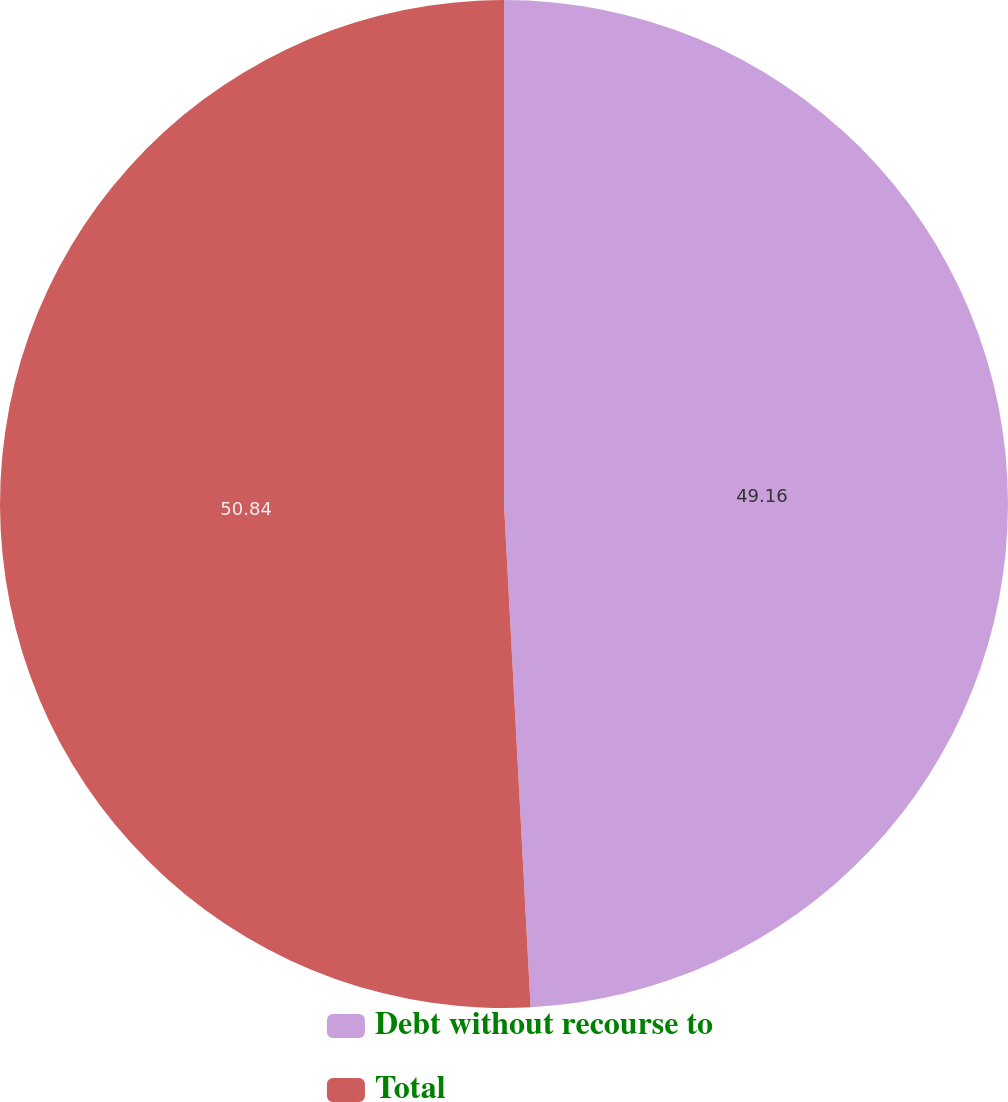<chart> <loc_0><loc_0><loc_500><loc_500><pie_chart><fcel>Debt without recourse to<fcel>Total<nl><fcel>49.16%<fcel>50.84%<nl></chart> 